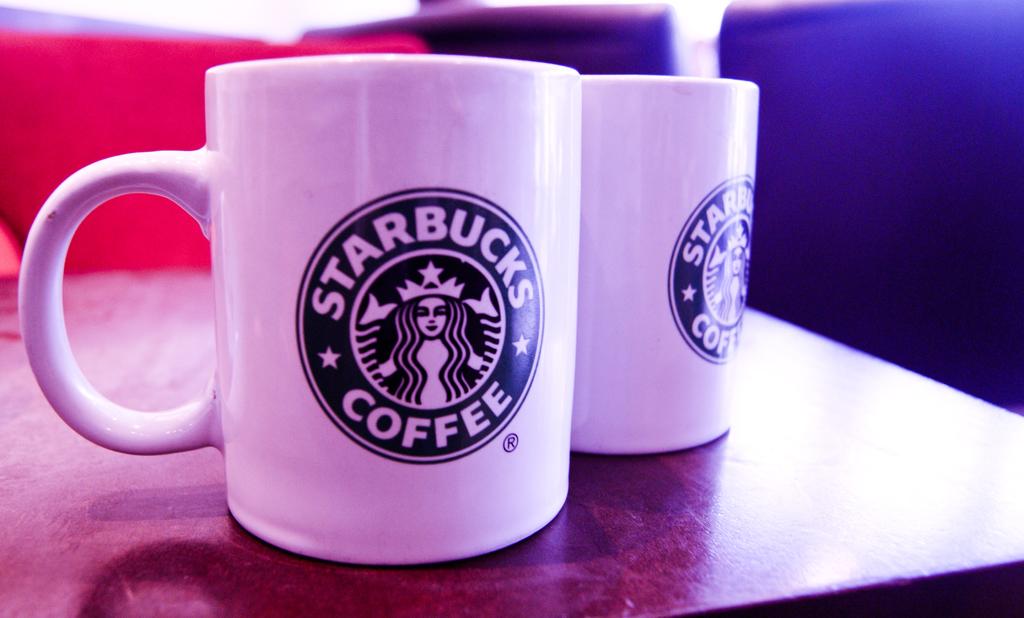What coffee company is the mug from?
Offer a terse response. Starbucks. 